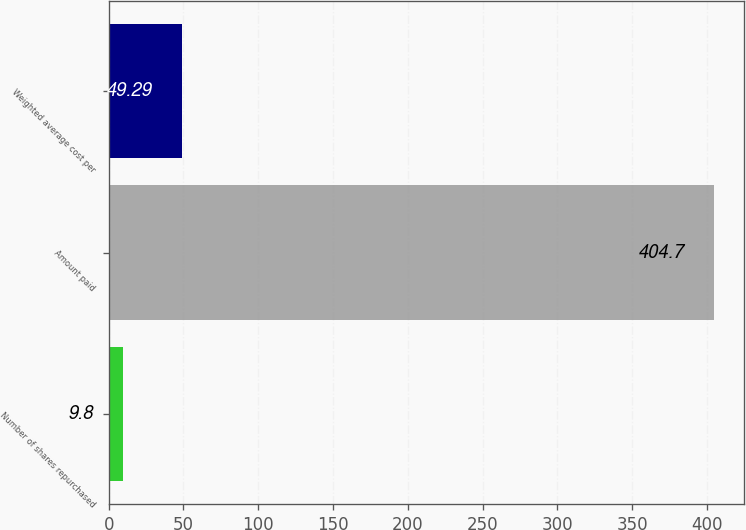<chart> <loc_0><loc_0><loc_500><loc_500><bar_chart><fcel>Number of shares repurchased<fcel>Amount paid<fcel>Weighted average cost per<nl><fcel>9.8<fcel>404.7<fcel>49.29<nl></chart> 